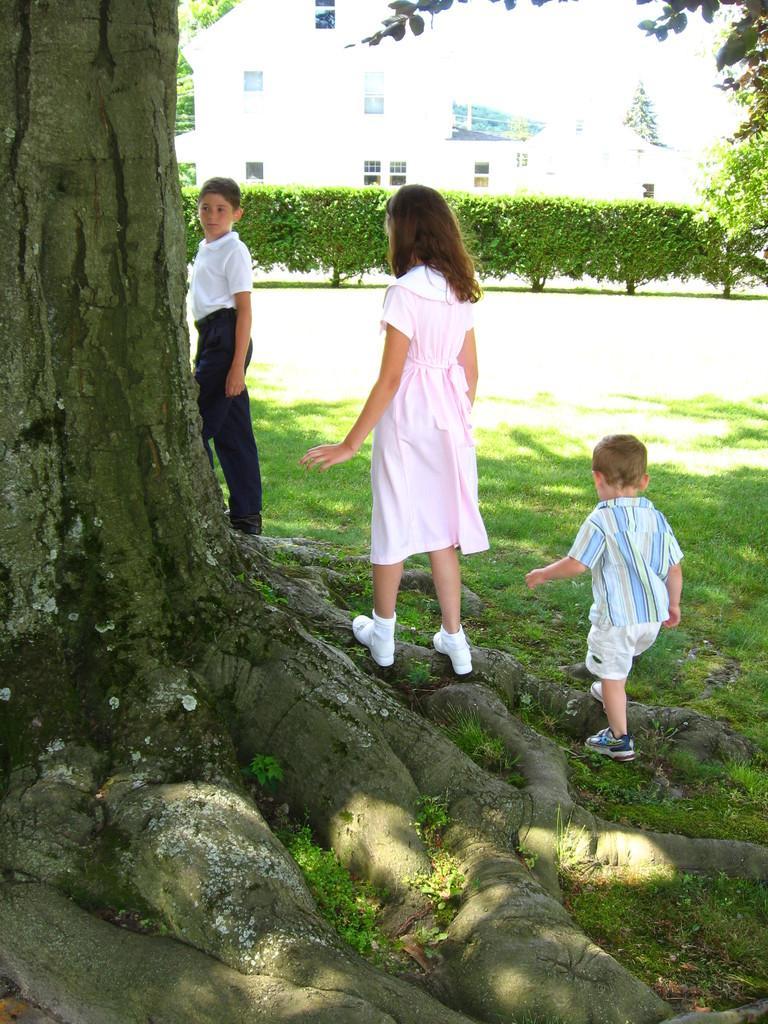In one or two sentences, can you explain what this image depicts? In this image in the foreground there is a tree and near the tree there are three children. 